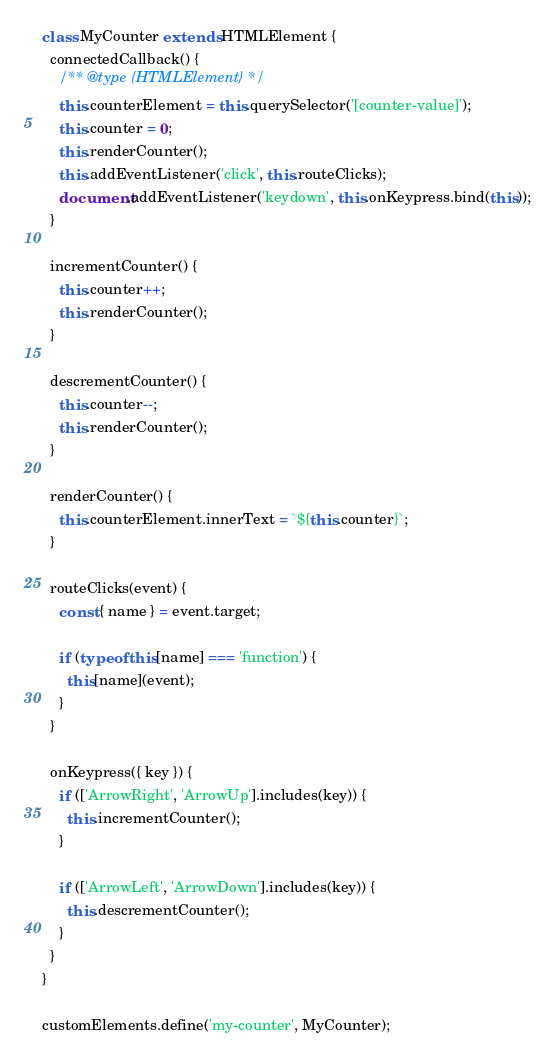<code> <loc_0><loc_0><loc_500><loc_500><_JavaScript_>class MyCounter extends HTMLElement {
  connectedCallback() {
    /** @type {HTMLElement} */
    this.counterElement = this.querySelector('[counter-value]');
    this.counter = 0;
    this.renderCounter();
    this.addEventListener('click', this.routeClicks);
    document.addEventListener('keydown', this.onKeypress.bind(this));
  }

  incrementCounter() {
    this.counter++;
    this.renderCounter();
  }

  descrementCounter() {
    this.counter--;
    this.renderCounter();
  }

  renderCounter() {
    this.counterElement.innerText = `${this.counter}`;
  }

  routeClicks(event) {
    const { name } = event.target;

    if (typeof this[name] === 'function') {
      this[name](event);
    }
  }

  onKeypress({ key }) {
    if (['ArrowRight', 'ArrowUp'].includes(key)) {
      this.incrementCounter();
    }

    if (['ArrowLeft', 'ArrowDown'].includes(key)) {
      this.descrementCounter();
    }
  }
}

customElements.define('my-counter', MyCounter);
</code> 